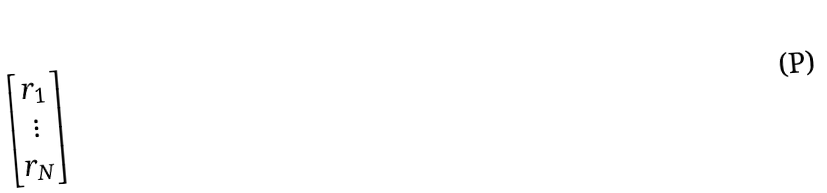Convert formula to latex. <formula><loc_0><loc_0><loc_500><loc_500>\begin{bmatrix} r _ { 1 } \\ \vdots \\ r _ { N } \end{bmatrix}</formula> 